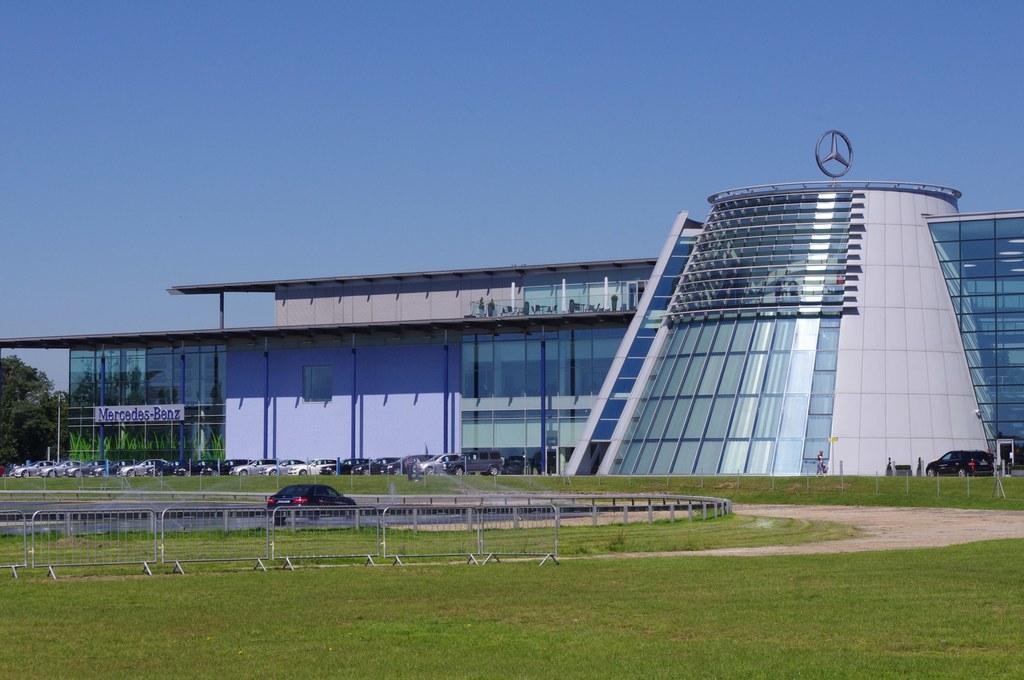Could you give a brief overview of what you see in this image? There is a fence and a grassy land at the bottom of this image. We can see a building, trees and cars in the middle of this image and the sky is in the background. 